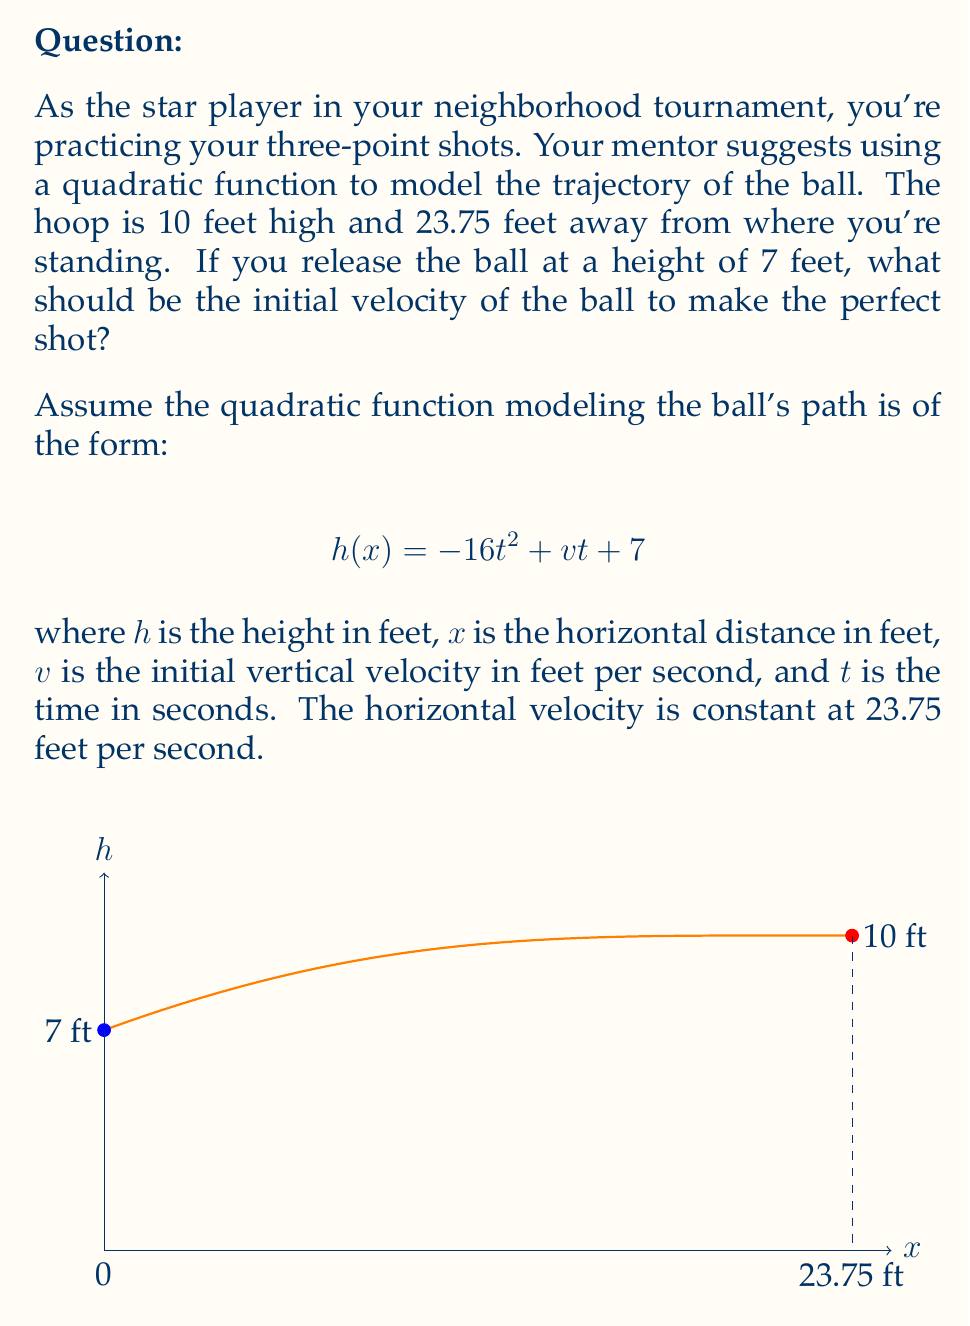Could you help me with this problem? Let's approach this step-by-step:

1) We know the ball starts at 7 feet high and needs to end at 10 feet high after traveling 23.75 feet horizontally.

2) We need to find the time it takes for the ball to reach the hoop. Since the horizontal velocity is constant at 23.75 ft/s, we can use:

   $t = \frac{23.75}{23.75} = 1$ second

3) Now we can use the quadratic function at $t = 1$ second:

   $$10 = -16(1)^2 + v(1) + 7$$

4) Simplify:

   $$10 = -16 + v + 7$$

5) Solve for $v$:

   $$v = 10 + 16 - 7 = 19$$

6) Therefore, the initial vertical velocity should be 19 ft/s.

7) To verify, let's plug this back into our original equation:

   $$h(t) = -16t^2 + 19t + 7$$

   At $t = 1$:
   $$h(1) = -16(1)^2 + 19(1) + 7 = -16 + 19 + 7 = 10$$

   This confirms that the ball will indeed reach a height of 10 feet after 1 second, which is exactly what we want.
Answer: 19 ft/s 